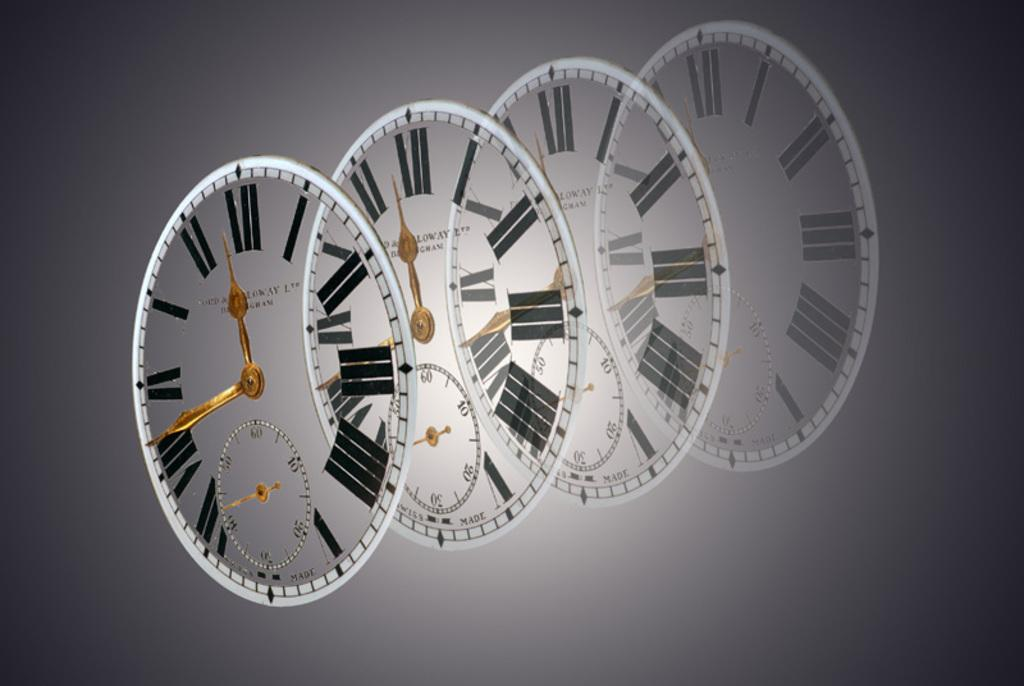<image>
Describe the image concisely. Four sets of clocks are lined up with two of them with their small hands pointed at 12. 